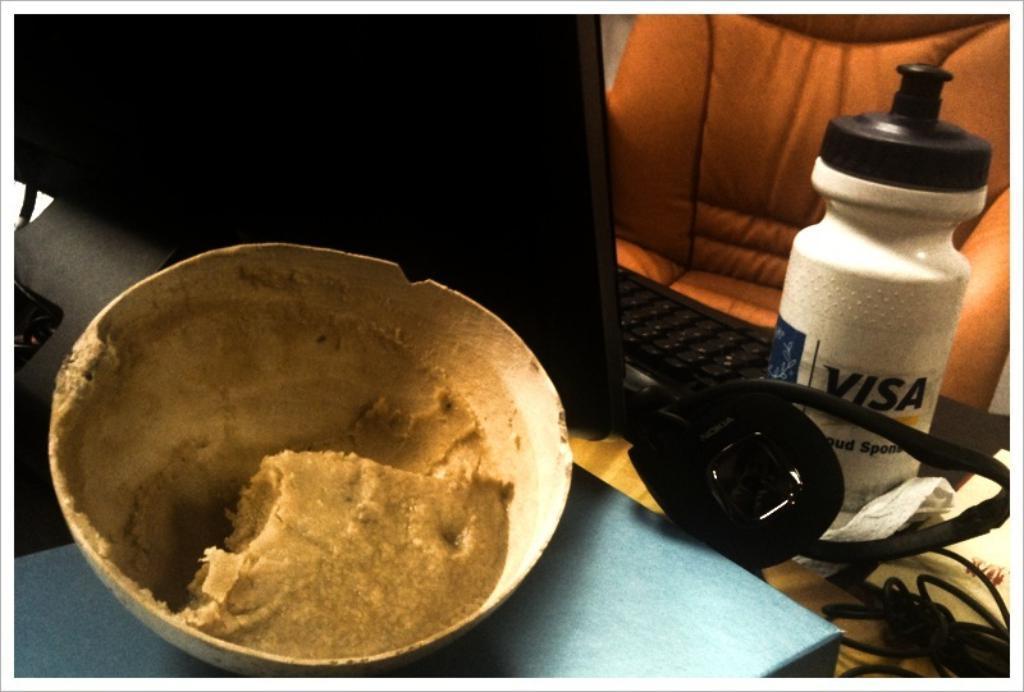Could you give a brief overview of what you see in this image? In the left bottom, there is a table on which bowl is kept. Next to that a laptop is there. On the right a chair is visible. And a bottle and headphones are visible. This image is taken inside a room. 